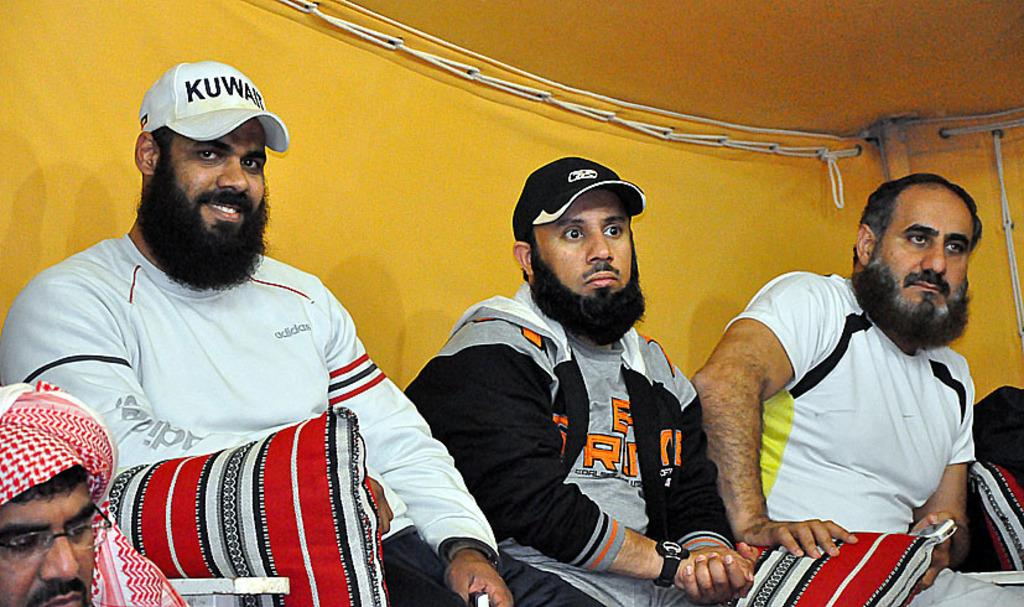Who or what can be seen in the image? There are people in the image. What objects are present in the image? There are pillows and other objects visible in the image. What color is the background of the image? The background of the image is yellow. What type of structure is visible in the image? There is a roof in the image, which suggests a building or shelter. What direction is the whip pointing in the image? There is no whip present in the image, so it cannot be determined which direction it would be pointing. 